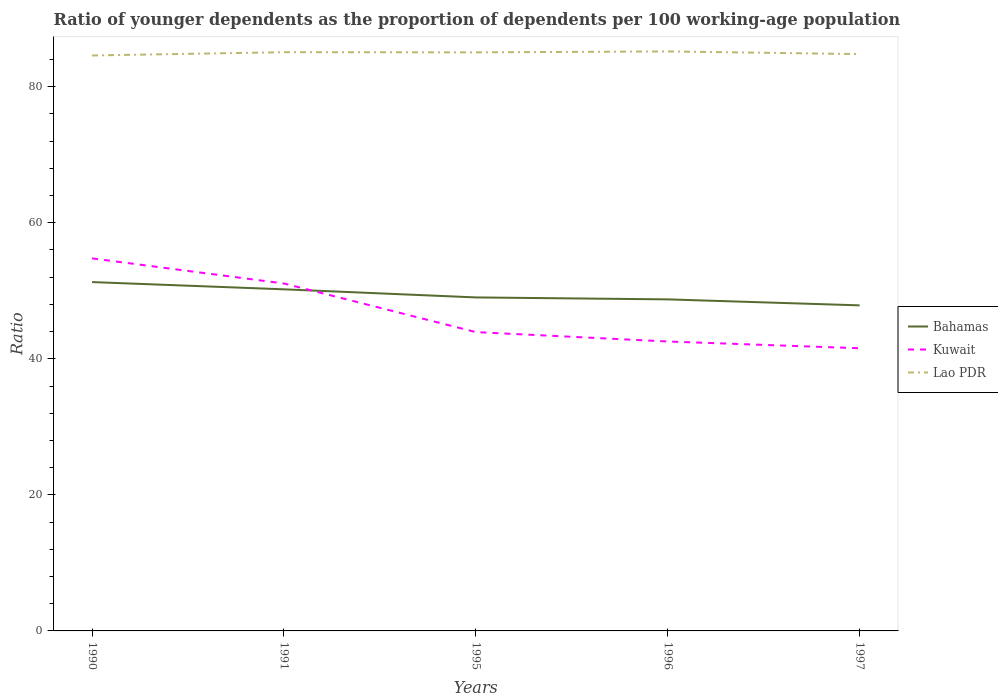How many different coloured lines are there?
Give a very brief answer. 3. Does the line corresponding to Lao PDR intersect with the line corresponding to Kuwait?
Your answer should be very brief. No. Is the number of lines equal to the number of legend labels?
Your response must be concise. Yes. Across all years, what is the maximum age dependency ratio(young) in Bahamas?
Offer a terse response. 47.86. What is the total age dependency ratio(young) in Lao PDR in the graph?
Keep it short and to the point. -0.48. What is the difference between the highest and the second highest age dependency ratio(young) in Lao PDR?
Keep it short and to the point. 0.6. How many lines are there?
Your answer should be very brief. 3. How many years are there in the graph?
Offer a very short reply. 5. What is the difference between two consecutive major ticks on the Y-axis?
Provide a short and direct response. 20. Are the values on the major ticks of Y-axis written in scientific E-notation?
Your answer should be very brief. No. How many legend labels are there?
Give a very brief answer. 3. What is the title of the graph?
Offer a very short reply. Ratio of younger dependents as the proportion of dependents per 100 working-age population. Does "Sri Lanka" appear as one of the legend labels in the graph?
Your answer should be very brief. No. What is the label or title of the X-axis?
Make the answer very short. Years. What is the label or title of the Y-axis?
Make the answer very short. Ratio. What is the Ratio in Bahamas in 1990?
Give a very brief answer. 51.28. What is the Ratio of Kuwait in 1990?
Your response must be concise. 54.76. What is the Ratio in Lao PDR in 1990?
Offer a terse response. 84.59. What is the Ratio of Bahamas in 1991?
Keep it short and to the point. 50.21. What is the Ratio in Kuwait in 1991?
Ensure brevity in your answer.  51.07. What is the Ratio of Lao PDR in 1991?
Ensure brevity in your answer.  85.08. What is the Ratio in Bahamas in 1995?
Provide a short and direct response. 49.03. What is the Ratio in Kuwait in 1995?
Ensure brevity in your answer.  43.93. What is the Ratio in Lao PDR in 1995?
Your response must be concise. 85.05. What is the Ratio in Bahamas in 1996?
Offer a terse response. 48.74. What is the Ratio of Kuwait in 1996?
Offer a very short reply. 42.55. What is the Ratio of Lao PDR in 1996?
Keep it short and to the point. 85.19. What is the Ratio of Bahamas in 1997?
Offer a very short reply. 47.86. What is the Ratio of Kuwait in 1997?
Provide a short and direct response. 41.55. What is the Ratio of Lao PDR in 1997?
Provide a short and direct response. 84.8. Across all years, what is the maximum Ratio in Bahamas?
Offer a terse response. 51.28. Across all years, what is the maximum Ratio of Kuwait?
Ensure brevity in your answer.  54.76. Across all years, what is the maximum Ratio in Lao PDR?
Ensure brevity in your answer.  85.19. Across all years, what is the minimum Ratio in Bahamas?
Your answer should be very brief. 47.86. Across all years, what is the minimum Ratio in Kuwait?
Make the answer very short. 41.55. Across all years, what is the minimum Ratio in Lao PDR?
Your response must be concise. 84.59. What is the total Ratio of Bahamas in the graph?
Keep it short and to the point. 247.12. What is the total Ratio in Kuwait in the graph?
Give a very brief answer. 233.86. What is the total Ratio in Lao PDR in the graph?
Offer a very short reply. 424.7. What is the difference between the Ratio in Bahamas in 1990 and that in 1991?
Offer a terse response. 1.07. What is the difference between the Ratio of Kuwait in 1990 and that in 1991?
Give a very brief answer. 3.69. What is the difference between the Ratio in Lao PDR in 1990 and that in 1991?
Make the answer very short. -0.48. What is the difference between the Ratio in Bahamas in 1990 and that in 1995?
Provide a succinct answer. 2.25. What is the difference between the Ratio in Kuwait in 1990 and that in 1995?
Provide a succinct answer. 10.84. What is the difference between the Ratio in Lao PDR in 1990 and that in 1995?
Offer a very short reply. -0.46. What is the difference between the Ratio of Bahamas in 1990 and that in 1996?
Keep it short and to the point. 2.54. What is the difference between the Ratio in Kuwait in 1990 and that in 1996?
Your response must be concise. 12.22. What is the difference between the Ratio in Lao PDR in 1990 and that in 1996?
Offer a terse response. -0.6. What is the difference between the Ratio of Bahamas in 1990 and that in 1997?
Your answer should be very brief. 3.42. What is the difference between the Ratio in Kuwait in 1990 and that in 1997?
Offer a terse response. 13.21. What is the difference between the Ratio in Lao PDR in 1990 and that in 1997?
Your response must be concise. -0.2. What is the difference between the Ratio of Bahamas in 1991 and that in 1995?
Make the answer very short. 1.19. What is the difference between the Ratio of Kuwait in 1991 and that in 1995?
Ensure brevity in your answer.  7.14. What is the difference between the Ratio in Lao PDR in 1991 and that in 1995?
Provide a short and direct response. 0.02. What is the difference between the Ratio of Bahamas in 1991 and that in 1996?
Ensure brevity in your answer.  1.48. What is the difference between the Ratio in Kuwait in 1991 and that in 1996?
Offer a terse response. 8.52. What is the difference between the Ratio in Lao PDR in 1991 and that in 1996?
Provide a succinct answer. -0.11. What is the difference between the Ratio in Bahamas in 1991 and that in 1997?
Make the answer very short. 2.35. What is the difference between the Ratio of Kuwait in 1991 and that in 1997?
Give a very brief answer. 9.52. What is the difference between the Ratio in Lao PDR in 1991 and that in 1997?
Your response must be concise. 0.28. What is the difference between the Ratio in Bahamas in 1995 and that in 1996?
Offer a very short reply. 0.29. What is the difference between the Ratio in Kuwait in 1995 and that in 1996?
Your answer should be very brief. 1.38. What is the difference between the Ratio of Lao PDR in 1995 and that in 1996?
Provide a short and direct response. -0.14. What is the difference between the Ratio of Bahamas in 1995 and that in 1997?
Offer a terse response. 1.17. What is the difference between the Ratio of Kuwait in 1995 and that in 1997?
Ensure brevity in your answer.  2.38. What is the difference between the Ratio of Lao PDR in 1995 and that in 1997?
Make the answer very short. 0.25. What is the difference between the Ratio of Bahamas in 1996 and that in 1997?
Ensure brevity in your answer.  0.88. What is the difference between the Ratio in Kuwait in 1996 and that in 1997?
Make the answer very short. 0.99. What is the difference between the Ratio of Lao PDR in 1996 and that in 1997?
Offer a terse response. 0.39. What is the difference between the Ratio in Bahamas in 1990 and the Ratio in Kuwait in 1991?
Offer a very short reply. 0.21. What is the difference between the Ratio of Bahamas in 1990 and the Ratio of Lao PDR in 1991?
Your response must be concise. -33.79. What is the difference between the Ratio of Kuwait in 1990 and the Ratio of Lao PDR in 1991?
Your response must be concise. -30.31. What is the difference between the Ratio in Bahamas in 1990 and the Ratio in Kuwait in 1995?
Provide a short and direct response. 7.35. What is the difference between the Ratio in Bahamas in 1990 and the Ratio in Lao PDR in 1995?
Offer a very short reply. -33.77. What is the difference between the Ratio in Kuwait in 1990 and the Ratio in Lao PDR in 1995?
Give a very brief answer. -30.29. What is the difference between the Ratio in Bahamas in 1990 and the Ratio in Kuwait in 1996?
Make the answer very short. 8.73. What is the difference between the Ratio of Bahamas in 1990 and the Ratio of Lao PDR in 1996?
Offer a terse response. -33.91. What is the difference between the Ratio of Kuwait in 1990 and the Ratio of Lao PDR in 1996?
Offer a terse response. -30.43. What is the difference between the Ratio of Bahamas in 1990 and the Ratio of Kuwait in 1997?
Your answer should be compact. 9.73. What is the difference between the Ratio of Bahamas in 1990 and the Ratio of Lao PDR in 1997?
Offer a very short reply. -33.52. What is the difference between the Ratio in Kuwait in 1990 and the Ratio in Lao PDR in 1997?
Your response must be concise. -30.03. What is the difference between the Ratio in Bahamas in 1991 and the Ratio in Kuwait in 1995?
Provide a succinct answer. 6.29. What is the difference between the Ratio in Bahamas in 1991 and the Ratio in Lao PDR in 1995?
Provide a succinct answer. -34.84. What is the difference between the Ratio in Kuwait in 1991 and the Ratio in Lao PDR in 1995?
Give a very brief answer. -33.98. What is the difference between the Ratio in Bahamas in 1991 and the Ratio in Kuwait in 1996?
Make the answer very short. 7.67. What is the difference between the Ratio of Bahamas in 1991 and the Ratio of Lao PDR in 1996?
Provide a short and direct response. -34.97. What is the difference between the Ratio in Kuwait in 1991 and the Ratio in Lao PDR in 1996?
Offer a very short reply. -34.12. What is the difference between the Ratio of Bahamas in 1991 and the Ratio of Kuwait in 1997?
Give a very brief answer. 8.66. What is the difference between the Ratio in Bahamas in 1991 and the Ratio in Lao PDR in 1997?
Your response must be concise. -34.58. What is the difference between the Ratio of Kuwait in 1991 and the Ratio of Lao PDR in 1997?
Your response must be concise. -33.73. What is the difference between the Ratio in Bahamas in 1995 and the Ratio in Kuwait in 1996?
Your response must be concise. 6.48. What is the difference between the Ratio of Bahamas in 1995 and the Ratio of Lao PDR in 1996?
Your response must be concise. -36.16. What is the difference between the Ratio of Kuwait in 1995 and the Ratio of Lao PDR in 1996?
Provide a short and direct response. -41.26. What is the difference between the Ratio in Bahamas in 1995 and the Ratio in Kuwait in 1997?
Make the answer very short. 7.48. What is the difference between the Ratio in Bahamas in 1995 and the Ratio in Lao PDR in 1997?
Provide a succinct answer. -35.77. What is the difference between the Ratio in Kuwait in 1995 and the Ratio in Lao PDR in 1997?
Offer a terse response. -40.87. What is the difference between the Ratio of Bahamas in 1996 and the Ratio of Kuwait in 1997?
Give a very brief answer. 7.19. What is the difference between the Ratio in Bahamas in 1996 and the Ratio in Lao PDR in 1997?
Your response must be concise. -36.06. What is the difference between the Ratio of Kuwait in 1996 and the Ratio of Lao PDR in 1997?
Your answer should be compact. -42.25. What is the average Ratio in Bahamas per year?
Offer a terse response. 49.42. What is the average Ratio of Kuwait per year?
Give a very brief answer. 46.77. What is the average Ratio of Lao PDR per year?
Provide a short and direct response. 84.94. In the year 1990, what is the difference between the Ratio of Bahamas and Ratio of Kuwait?
Provide a succinct answer. -3.48. In the year 1990, what is the difference between the Ratio of Bahamas and Ratio of Lao PDR?
Ensure brevity in your answer.  -33.31. In the year 1990, what is the difference between the Ratio in Kuwait and Ratio in Lao PDR?
Your response must be concise. -29.83. In the year 1991, what is the difference between the Ratio of Bahamas and Ratio of Kuwait?
Your answer should be very brief. -0.86. In the year 1991, what is the difference between the Ratio in Bahamas and Ratio in Lao PDR?
Provide a succinct answer. -34.86. In the year 1991, what is the difference between the Ratio in Kuwait and Ratio in Lao PDR?
Give a very brief answer. -34.01. In the year 1995, what is the difference between the Ratio in Bahamas and Ratio in Kuwait?
Give a very brief answer. 5.1. In the year 1995, what is the difference between the Ratio of Bahamas and Ratio of Lao PDR?
Your response must be concise. -36.02. In the year 1995, what is the difference between the Ratio of Kuwait and Ratio of Lao PDR?
Your answer should be compact. -41.12. In the year 1996, what is the difference between the Ratio of Bahamas and Ratio of Kuwait?
Offer a terse response. 6.19. In the year 1996, what is the difference between the Ratio of Bahamas and Ratio of Lao PDR?
Offer a terse response. -36.45. In the year 1996, what is the difference between the Ratio of Kuwait and Ratio of Lao PDR?
Your answer should be compact. -42.64. In the year 1997, what is the difference between the Ratio of Bahamas and Ratio of Kuwait?
Offer a very short reply. 6.31. In the year 1997, what is the difference between the Ratio of Bahamas and Ratio of Lao PDR?
Your answer should be compact. -36.94. In the year 1997, what is the difference between the Ratio in Kuwait and Ratio in Lao PDR?
Provide a short and direct response. -43.24. What is the ratio of the Ratio in Bahamas in 1990 to that in 1991?
Ensure brevity in your answer.  1.02. What is the ratio of the Ratio of Kuwait in 1990 to that in 1991?
Ensure brevity in your answer.  1.07. What is the ratio of the Ratio of Lao PDR in 1990 to that in 1991?
Provide a short and direct response. 0.99. What is the ratio of the Ratio of Bahamas in 1990 to that in 1995?
Give a very brief answer. 1.05. What is the ratio of the Ratio in Kuwait in 1990 to that in 1995?
Offer a terse response. 1.25. What is the ratio of the Ratio in Bahamas in 1990 to that in 1996?
Give a very brief answer. 1.05. What is the ratio of the Ratio in Kuwait in 1990 to that in 1996?
Make the answer very short. 1.29. What is the ratio of the Ratio of Bahamas in 1990 to that in 1997?
Your answer should be very brief. 1.07. What is the ratio of the Ratio in Kuwait in 1990 to that in 1997?
Your response must be concise. 1.32. What is the ratio of the Ratio of Bahamas in 1991 to that in 1995?
Offer a terse response. 1.02. What is the ratio of the Ratio of Kuwait in 1991 to that in 1995?
Your response must be concise. 1.16. What is the ratio of the Ratio of Bahamas in 1991 to that in 1996?
Provide a succinct answer. 1.03. What is the ratio of the Ratio in Kuwait in 1991 to that in 1996?
Provide a succinct answer. 1.2. What is the ratio of the Ratio in Bahamas in 1991 to that in 1997?
Ensure brevity in your answer.  1.05. What is the ratio of the Ratio of Kuwait in 1991 to that in 1997?
Your answer should be very brief. 1.23. What is the ratio of the Ratio in Bahamas in 1995 to that in 1996?
Your response must be concise. 1.01. What is the ratio of the Ratio of Kuwait in 1995 to that in 1996?
Your response must be concise. 1.03. What is the ratio of the Ratio of Bahamas in 1995 to that in 1997?
Offer a very short reply. 1.02. What is the ratio of the Ratio in Kuwait in 1995 to that in 1997?
Ensure brevity in your answer.  1.06. What is the ratio of the Ratio of Lao PDR in 1995 to that in 1997?
Keep it short and to the point. 1. What is the ratio of the Ratio of Bahamas in 1996 to that in 1997?
Provide a succinct answer. 1.02. What is the ratio of the Ratio of Kuwait in 1996 to that in 1997?
Ensure brevity in your answer.  1.02. What is the ratio of the Ratio of Lao PDR in 1996 to that in 1997?
Provide a short and direct response. 1. What is the difference between the highest and the second highest Ratio of Bahamas?
Offer a terse response. 1.07. What is the difference between the highest and the second highest Ratio of Kuwait?
Provide a short and direct response. 3.69. What is the difference between the highest and the second highest Ratio of Lao PDR?
Give a very brief answer. 0.11. What is the difference between the highest and the lowest Ratio in Bahamas?
Ensure brevity in your answer.  3.42. What is the difference between the highest and the lowest Ratio in Kuwait?
Your answer should be compact. 13.21. What is the difference between the highest and the lowest Ratio in Lao PDR?
Provide a succinct answer. 0.6. 